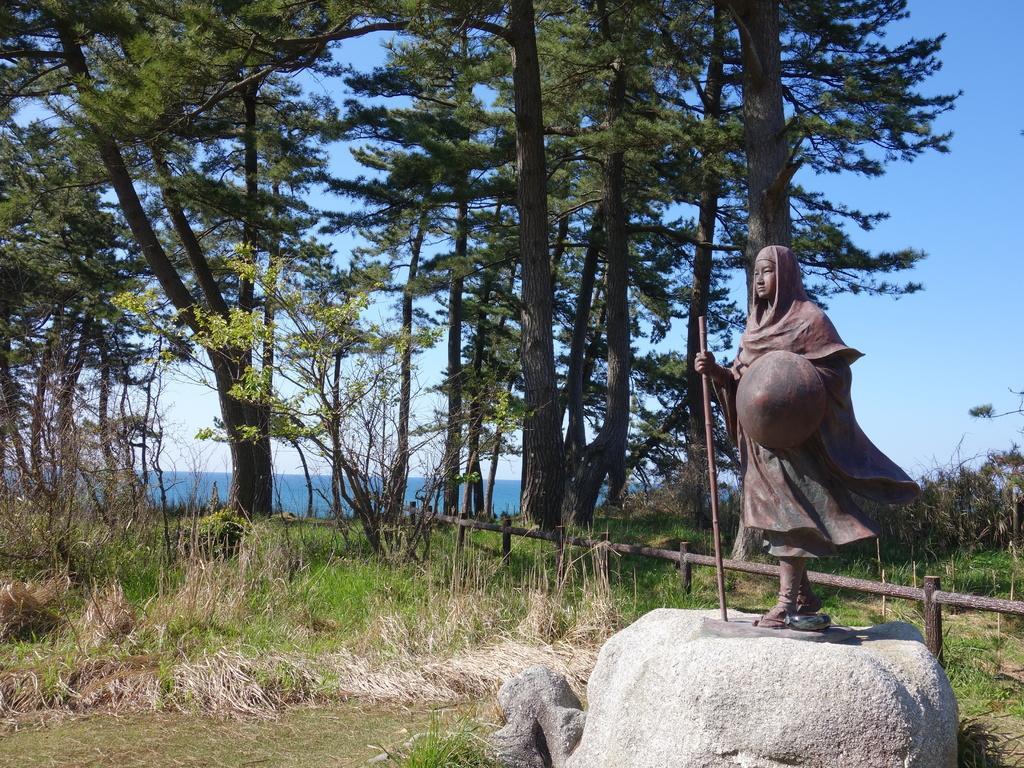In one or two sentences, can you explain what this image depicts? This picture is clicked outside. On the right we can see the sculpture of a person holding some objects and standing and we can see the grass and metal rods. In the background we can see the sky, trees, plants and a water body. 